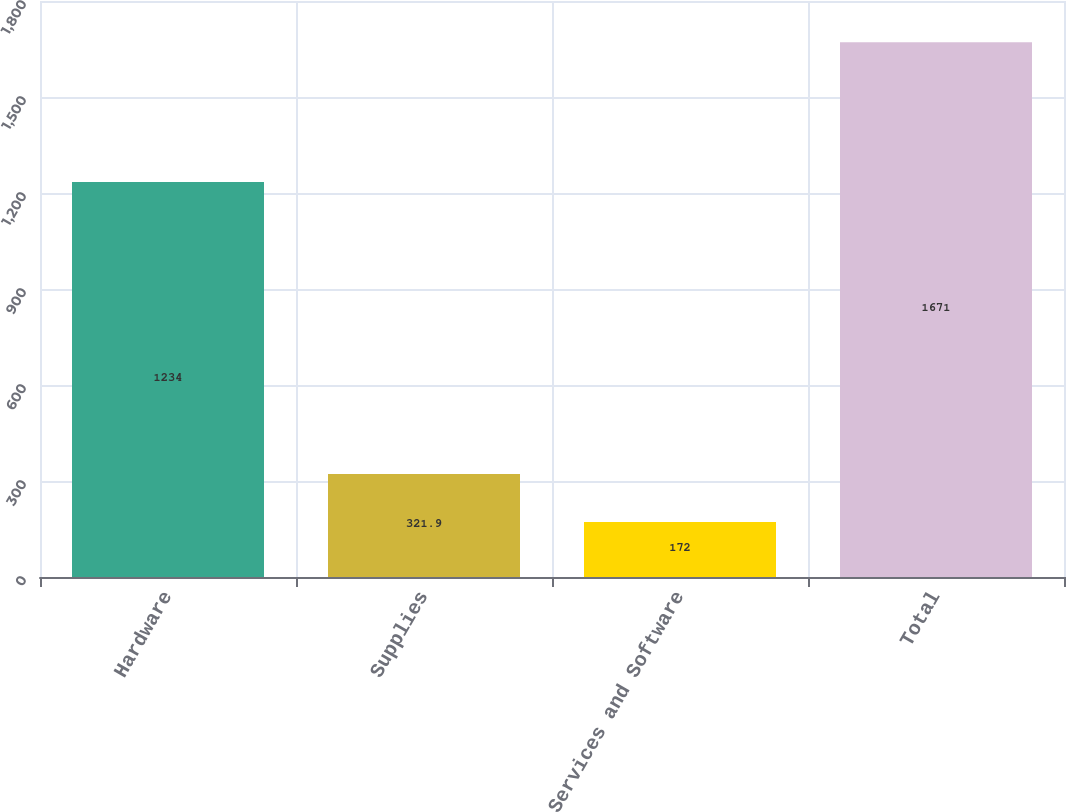Convert chart. <chart><loc_0><loc_0><loc_500><loc_500><bar_chart><fcel>Hardware<fcel>Supplies<fcel>Services and Software<fcel>Total<nl><fcel>1234<fcel>321.9<fcel>172<fcel>1671<nl></chart> 